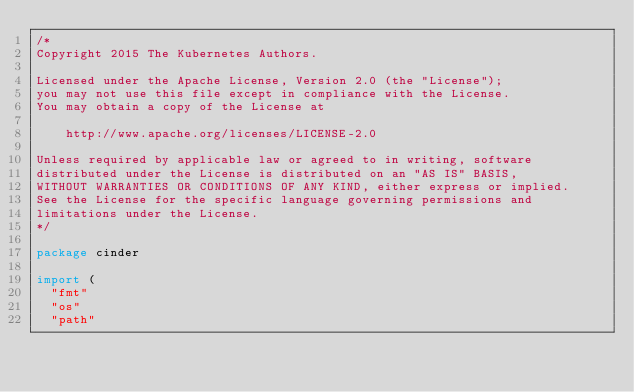Convert code to text. <code><loc_0><loc_0><loc_500><loc_500><_Go_>/*
Copyright 2015 The Kubernetes Authors.

Licensed under the Apache License, Version 2.0 (the "License");
you may not use this file except in compliance with the License.
You may obtain a copy of the License at

    http://www.apache.org/licenses/LICENSE-2.0

Unless required by applicable law or agreed to in writing, software
distributed under the License is distributed on an "AS IS" BASIS,
WITHOUT WARRANTIES OR CONDITIONS OF ANY KIND, either express or implied.
See the License for the specific language governing permissions and
limitations under the License.
*/

package cinder

import (
	"fmt"
	"os"
	"path"</code> 